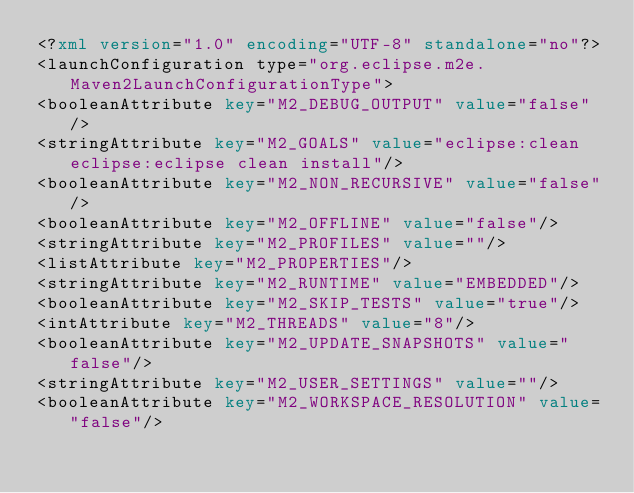Convert code to text. <code><loc_0><loc_0><loc_500><loc_500><_XML_><?xml version="1.0" encoding="UTF-8" standalone="no"?>
<launchConfiguration type="org.eclipse.m2e.Maven2LaunchConfigurationType">
<booleanAttribute key="M2_DEBUG_OUTPUT" value="false"/>
<stringAttribute key="M2_GOALS" value="eclipse:clean eclipse:eclipse clean install"/>
<booleanAttribute key="M2_NON_RECURSIVE" value="false"/>
<booleanAttribute key="M2_OFFLINE" value="false"/>
<stringAttribute key="M2_PROFILES" value=""/>
<listAttribute key="M2_PROPERTIES"/>
<stringAttribute key="M2_RUNTIME" value="EMBEDDED"/>
<booleanAttribute key="M2_SKIP_TESTS" value="true"/>
<intAttribute key="M2_THREADS" value="8"/>
<booleanAttribute key="M2_UPDATE_SNAPSHOTS" value="false"/>
<stringAttribute key="M2_USER_SETTINGS" value=""/>
<booleanAttribute key="M2_WORKSPACE_RESOLUTION" value="false"/></code> 